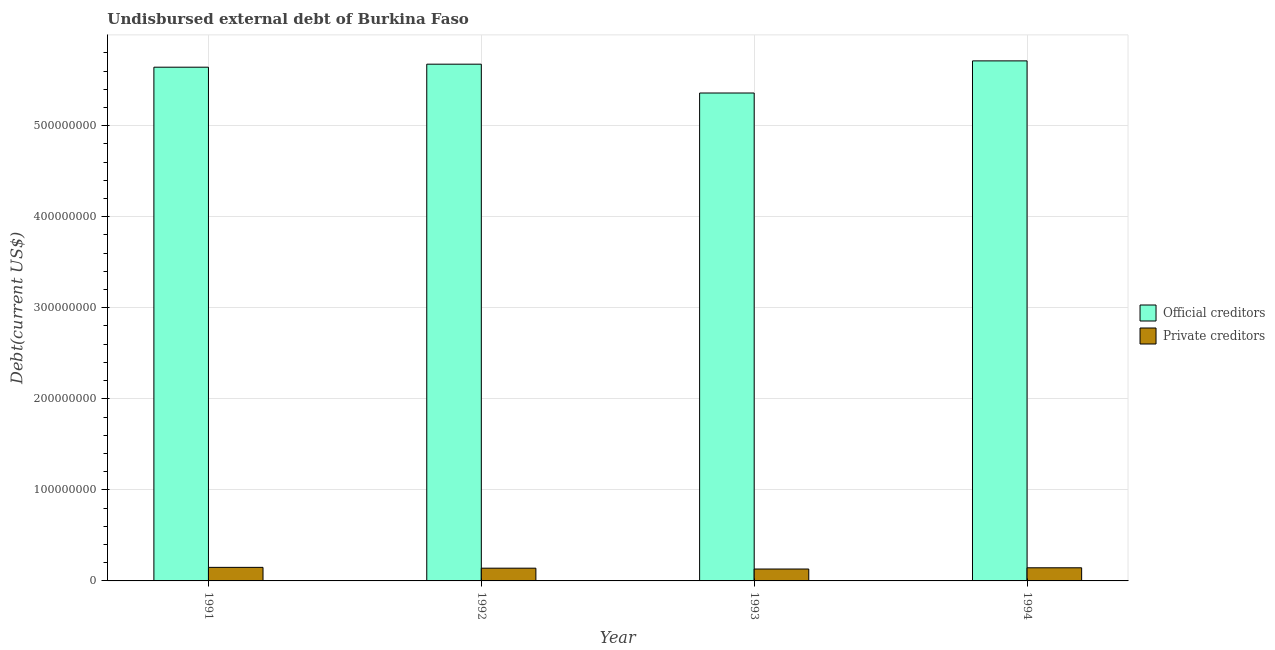Are the number of bars per tick equal to the number of legend labels?
Make the answer very short. Yes. How many bars are there on the 4th tick from the right?
Make the answer very short. 2. What is the label of the 2nd group of bars from the left?
Offer a terse response. 1992. What is the undisbursed external debt of official creditors in 1991?
Your response must be concise. 5.64e+08. Across all years, what is the maximum undisbursed external debt of private creditors?
Your response must be concise. 1.49e+07. Across all years, what is the minimum undisbursed external debt of official creditors?
Offer a terse response. 5.36e+08. In which year was the undisbursed external debt of official creditors minimum?
Offer a terse response. 1993. What is the total undisbursed external debt of private creditors in the graph?
Offer a very short reply. 5.64e+07. What is the difference between the undisbursed external debt of official creditors in 1992 and that in 1993?
Your answer should be compact. 3.17e+07. What is the difference between the undisbursed external debt of official creditors in 1994 and the undisbursed external debt of private creditors in 1991?
Your answer should be very brief. 6.93e+06. What is the average undisbursed external debt of private creditors per year?
Offer a very short reply. 1.41e+07. What is the ratio of the undisbursed external debt of official creditors in 1992 to that in 1993?
Your answer should be compact. 1.06. What is the difference between the highest and the second highest undisbursed external debt of private creditors?
Make the answer very short. 4.62e+05. What is the difference between the highest and the lowest undisbursed external debt of official creditors?
Offer a very short reply. 3.53e+07. What does the 2nd bar from the left in 1991 represents?
Provide a succinct answer. Private creditors. What does the 2nd bar from the right in 1991 represents?
Give a very brief answer. Official creditors. How many bars are there?
Make the answer very short. 8. Are all the bars in the graph horizontal?
Give a very brief answer. No. What is the difference between two consecutive major ticks on the Y-axis?
Ensure brevity in your answer.  1.00e+08. Does the graph contain any zero values?
Offer a very short reply. No. Where does the legend appear in the graph?
Your answer should be compact. Center right. How are the legend labels stacked?
Keep it short and to the point. Vertical. What is the title of the graph?
Give a very brief answer. Undisbursed external debt of Burkina Faso. Does "Diarrhea" appear as one of the legend labels in the graph?
Your response must be concise. No. What is the label or title of the X-axis?
Offer a very short reply. Year. What is the label or title of the Y-axis?
Your answer should be very brief. Debt(current US$). What is the Debt(current US$) of Official creditors in 1991?
Your answer should be very brief. 5.64e+08. What is the Debt(current US$) in Private creditors in 1991?
Your response must be concise. 1.49e+07. What is the Debt(current US$) in Official creditors in 1992?
Offer a very short reply. 5.67e+08. What is the Debt(current US$) in Private creditors in 1992?
Make the answer very short. 1.40e+07. What is the Debt(current US$) in Official creditors in 1993?
Make the answer very short. 5.36e+08. What is the Debt(current US$) of Private creditors in 1993?
Your response must be concise. 1.31e+07. What is the Debt(current US$) in Official creditors in 1994?
Ensure brevity in your answer.  5.71e+08. What is the Debt(current US$) of Private creditors in 1994?
Your response must be concise. 1.44e+07. Across all years, what is the maximum Debt(current US$) of Official creditors?
Offer a very short reply. 5.71e+08. Across all years, what is the maximum Debt(current US$) of Private creditors?
Give a very brief answer. 1.49e+07. Across all years, what is the minimum Debt(current US$) in Official creditors?
Offer a terse response. 5.36e+08. Across all years, what is the minimum Debt(current US$) of Private creditors?
Provide a short and direct response. 1.31e+07. What is the total Debt(current US$) of Official creditors in the graph?
Keep it short and to the point. 2.24e+09. What is the total Debt(current US$) of Private creditors in the graph?
Offer a terse response. 5.64e+07. What is the difference between the Debt(current US$) of Official creditors in 1991 and that in 1992?
Give a very brief answer. -3.30e+06. What is the difference between the Debt(current US$) of Private creditors in 1991 and that in 1992?
Your answer should be very brief. 8.82e+05. What is the difference between the Debt(current US$) in Official creditors in 1991 and that in 1993?
Your answer should be very brief. 2.84e+07. What is the difference between the Debt(current US$) of Private creditors in 1991 and that in 1993?
Offer a very short reply. 1.80e+06. What is the difference between the Debt(current US$) in Official creditors in 1991 and that in 1994?
Offer a very short reply. -6.93e+06. What is the difference between the Debt(current US$) of Private creditors in 1991 and that in 1994?
Provide a short and direct response. 4.62e+05. What is the difference between the Debt(current US$) in Official creditors in 1992 and that in 1993?
Your answer should be compact. 3.17e+07. What is the difference between the Debt(current US$) in Private creditors in 1992 and that in 1993?
Your answer should be compact. 9.23e+05. What is the difference between the Debt(current US$) in Official creditors in 1992 and that in 1994?
Your answer should be compact. -3.63e+06. What is the difference between the Debt(current US$) in Private creditors in 1992 and that in 1994?
Give a very brief answer. -4.20e+05. What is the difference between the Debt(current US$) in Official creditors in 1993 and that in 1994?
Make the answer very short. -3.53e+07. What is the difference between the Debt(current US$) in Private creditors in 1993 and that in 1994?
Your answer should be very brief. -1.34e+06. What is the difference between the Debt(current US$) in Official creditors in 1991 and the Debt(current US$) in Private creditors in 1992?
Make the answer very short. 5.50e+08. What is the difference between the Debt(current US$) in Official creditors in 1991 and the Debt(current US$) in Private creditors in 1993?
Provide a short and direct response. 5.51e+08. What is the difference between the Debt(current US$) in Official creditors in 1991 and the Debt(current US$) in Private creditors in 1994?
Provide a short and direct response. 5.50e+08. What is the difference between the Debt(current US$) of Official creditors in 1992 and the Debt(current US$) of Private creditors in 1993?
Offer a terse response. 5.54e+08. What is the difference between the Debt(current US$) of Official creditors in 1992 and the Debt(current US$) of Private creditors in 1994?
Make the answer very short. 5.53e+08. What is the difference between the Debt(current US$) in Official creditors in 1993 and the Debt(current US$) in Private creditors in 1994?
Your answer should be very brief. 5.21e+08. What is the average Debt(current US$) of Official creditors per year?
Keep it short and to the point. 5.60e+08. What is the average Debt(current US$) of Private creditors per year?
Provide a succinct answer. 1.41e+07. In the year 1991, what is the difference between the Debt(current US$) in Official creditors and Debt(current US$) in Private creditors?
Provide a succinct answer. 5.49e+08. In the year 1992, what is the difference between the Debt(current US$) of Official creditors and Debt(current US$) of Private creditors?
Provide a succinct answer. 5.53e+08. In the year 1993, what is the difference between the Debt(current US$) of Official creditors and Debt(current US$) of Private creditors?
Your answer should be very brief. 5.23e+08. In the year 1994, what is the difference between the Debt(current US$) in Official creditors and Debt(current US$) in Private creditors?
Your answer should be very brief. 5.57e+08. What is the ratio of the Debt(current US$) of Official creditors in 1991 to that in 1992?
Your answer should be compact. 0.99. What is the ratio of the Debt(current US$) in Private creditors in 1991 to that in 1992?
Provide a succinct answer. 1.06. What is the ratio of the Debt(current US$) in Official creditors in 1991 to that in 1993?
Keep it short and to the point. 1.05. What is the ratio of the Debt(current US$) of Private creditors in 1991 to that in 1993?
Keep it short and to the point. 1.14. What is the ratio of the Debt(current US$) in Official creditors in 1991 to that in 1994?
Keep it short and to the point. 0.99. What is the ratio of the Debt(current US$) in Private creditors in 1991 to that in 1994?
Offer a terse response. 1.03. What is the ratio of the Debt(current US$) in Official creditors in 1992 to that in 1993?
Provide a succinct answer. 1.06. What is the ratio of the Debt(current US$) in Private creditors in 1992 to that in 1993?
Keep it short and to the point. 1.07. What is the ratio of the Debt(current US$) of Private creditors in 1992 to that in 1994?
Make the answer very short. 0.97. What is the ratio of the Debt(current US$) of Official creditors in 1993 to that in 1994?
Make the answer very short. 0.94. What is the ratio of the Debt(current US$) in Private creditors in 1993 to that in 1994?
Your answer should be compact. 0.91. What is the difference between the highest and the second highest Debt(current US$) in Official creditors?
Provide a short and direct response. 3.63e+06. What is the difference between the highest and the second highest Debt(current US$) of Private creditors?
Offer a terse response. 4.62e+05. What is the difference between the highest and the lowest Debt(current US$) of Official creditors?
Your answer should be very brief. 3.53e+07. What is the difference between the highest and the lowest Debt(current US$) in Private creditors?
Offer a very short reply. 1.80e+06. 